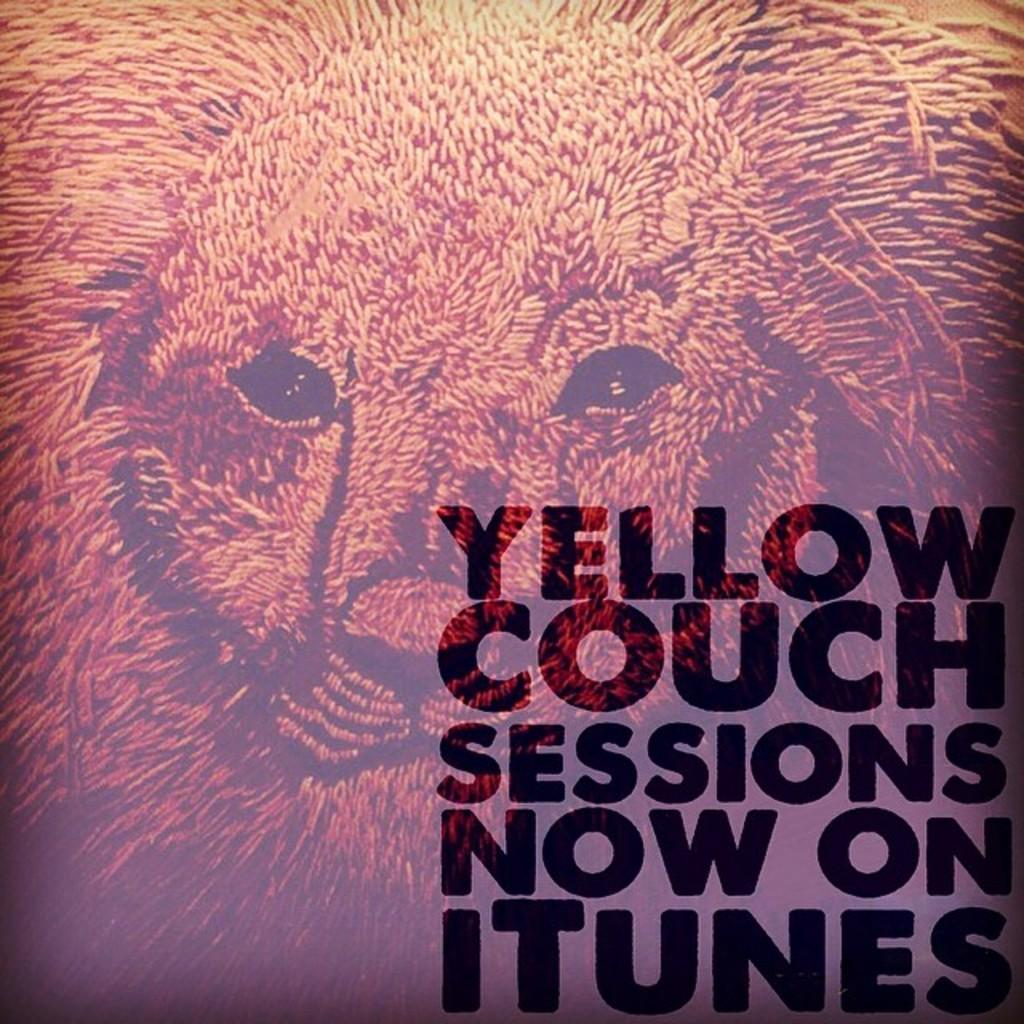What is the main feature in the center of the image? There is a watermark of a lion in the center of the image. What type of vegetation can be seen at the bottom of the image? There is grass at the bottom of the image. What type of clam is visible in the image? There is no clam present in the image. What kind of furniture can be seen in the image? There is: There is no furniture present in the image. 